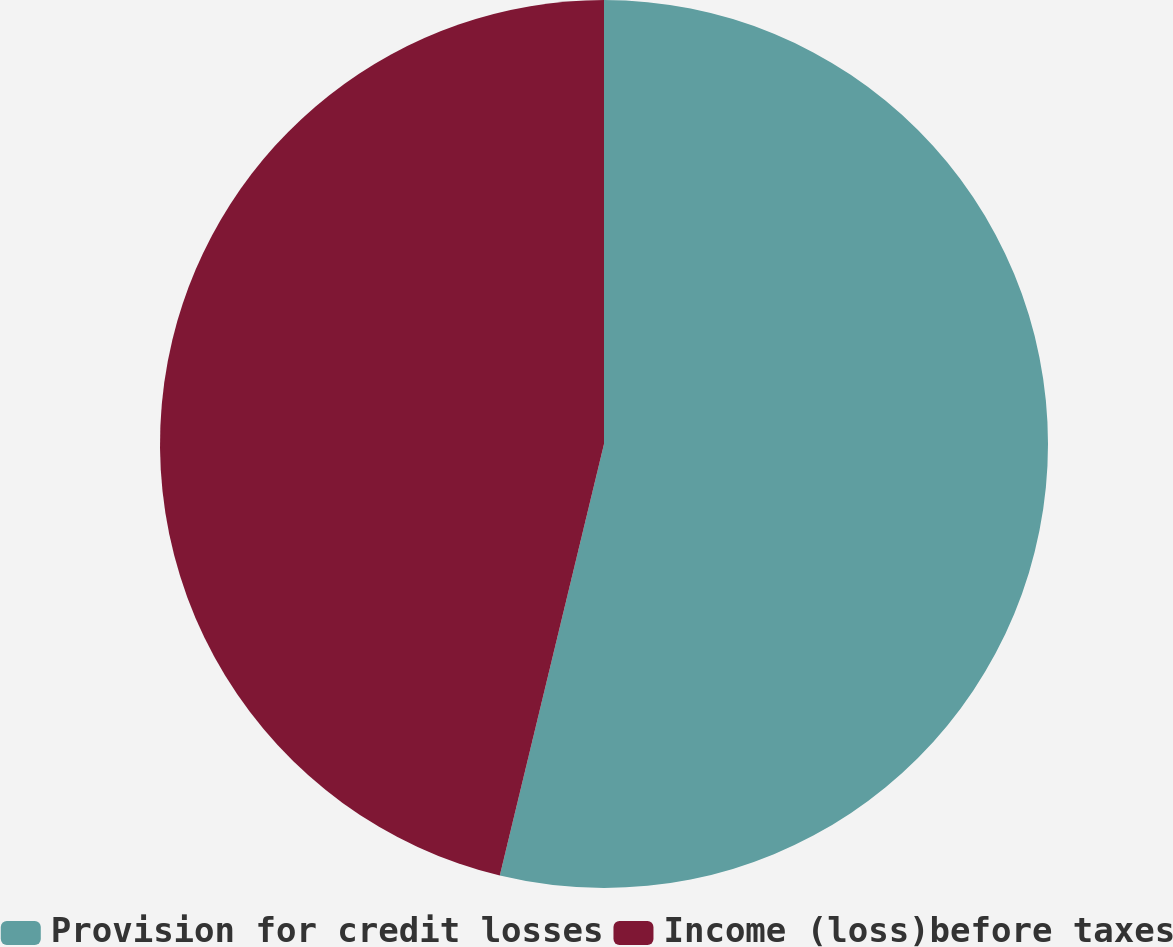<chart> <loc_0><loc_0><loc_500><loc_500><pie_chart><fcel>Provision for credit losses<fcel>Income (loss)before taxes<nl><fcel>53.77%<fcel>46.23%<nl></chart> 